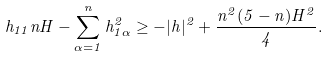<formula> <loc_0><loc_0><loc_500><loc_500>h _ { 1 1 } n H - \sum _ { \alpha = 1 } ^ { n } h _ { 1 \alpha } ^ { 2 } \geq - | h | ^ { 2 } + \frac { n ^ { 2 } ( 5 - n ) H ^ { 2 } } { 4 } .</formula> 